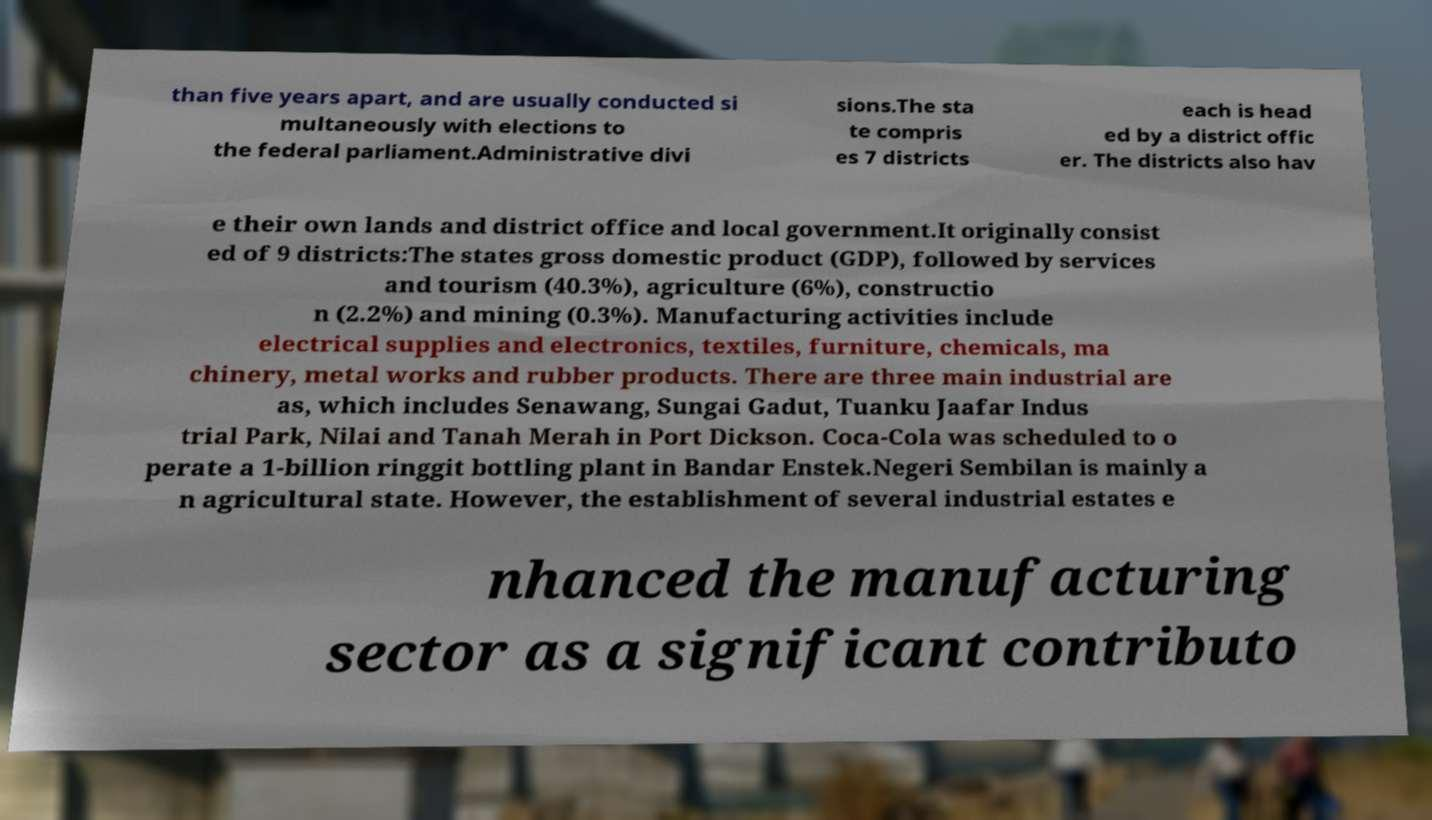For documentation purposes, I need the text within this image transcribed. Could you provide that? than five years apart, and are usually conducted si multaneously with elections to the federal parliament.Administrative divi sions.The sta te compris es 7 districts each is head ed by a district offic er. The districts also hav e their own lands and district office and local government.It originally consist ed of 9 districts:The states gross domestic product (GDP), followed by services and tourism (40.3%), agriculture (6%), constructio n (2.2%) and mining (0.3%). Manufacturing activities include electrical supplies and electronics, textiles, furniture, chemicals, ma chinery, metal works and rubber products. There are three main industrial are as, which includes Senawang, Sungai Gadut, Tuanku Jaafar Indus trial Park, Nilai and Tanah Merah in Port Dickson. Coca-Cola was scheduled to o perate a 1-billion ringgit bottling plant in Bandar Enstek.Negeri Sembilan is mainly a n agricultural state. However, the establishment of several industrial estates e nhanced the manufacturing sector as a significant contributo 